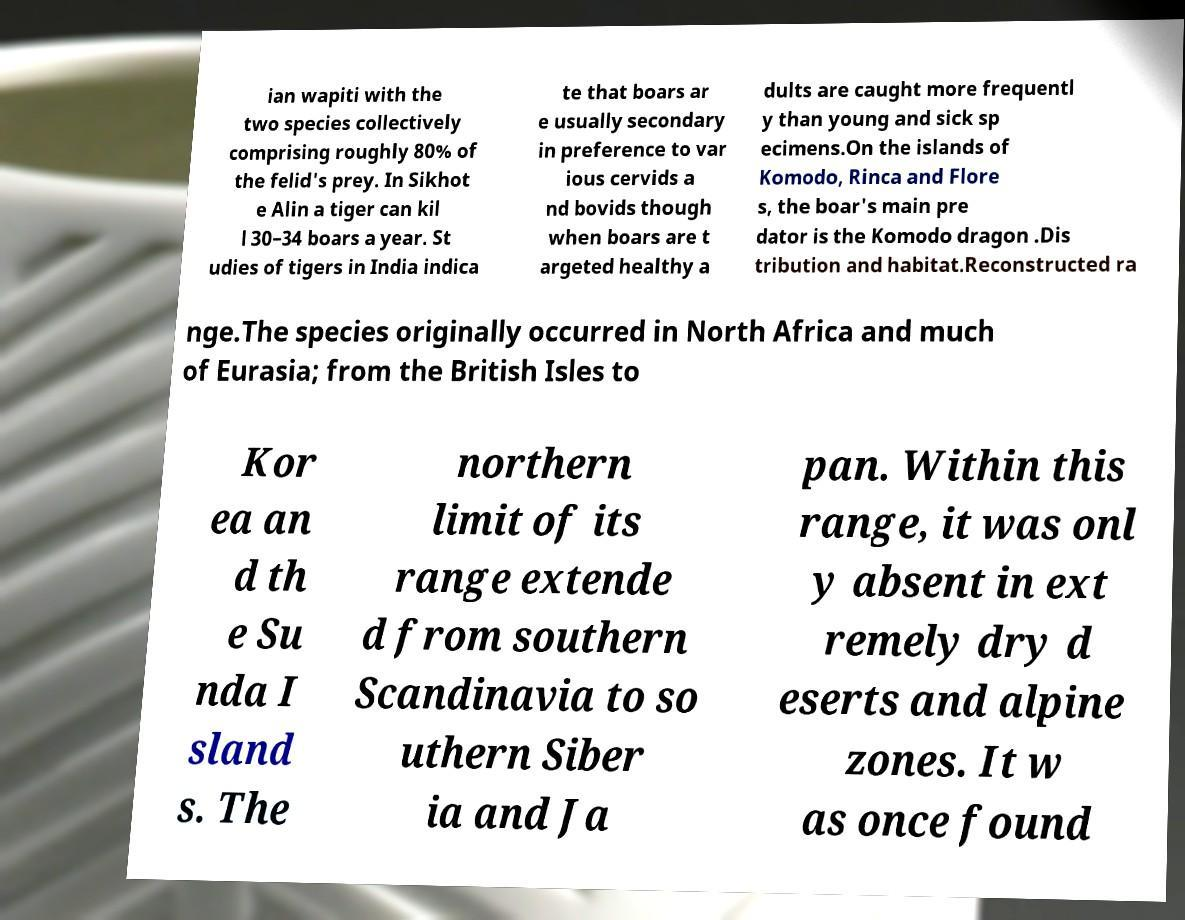Please identify and transcribe the text found in this image. ian wapiti with the two species collectively comprising roughly 80% of the felid's prey. In Sikhot e Alin a tiger can kil l 30–34 boars a year. St udies of tigers in India indica te that boars ar e usually secondary in preference to var ious cervids a nd bovids though when boars are t argeted healthy a dults are caught more frequentl y than young and sick sp ecimens.On the islands of Komodo, Rinca and Flore s, the boar's main pre dator is the Komodo dragon .Dis tribution and habitat.Reconstructed ra nge.The species originally occurred in North Africa and much of Eurasia; from the British Isles to Kor ea an d th e Su nda I sland s. The northern limit of its range extende d from southern Scandinavia to so uthern Siber ia and Ja pan. Within this range, it was onl y absent in ext remely dry d eserts and alpine zones. It w as once found 